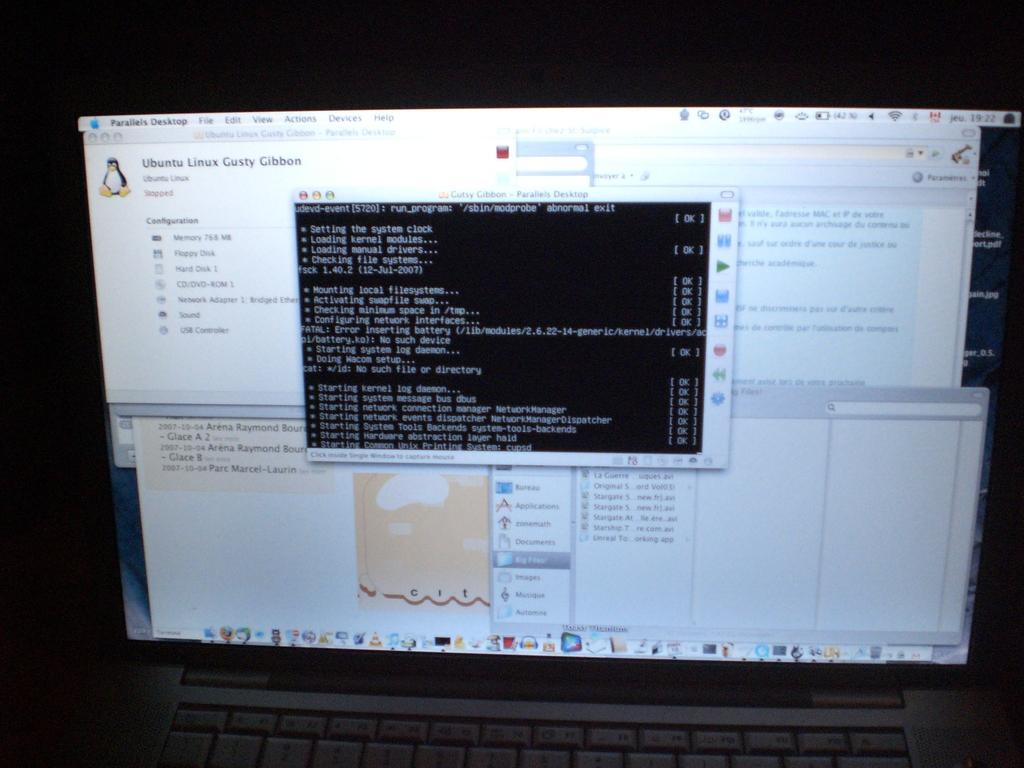<image>
Share a concise interpretation of the image provided. a program on a computer that says Ubuntu 